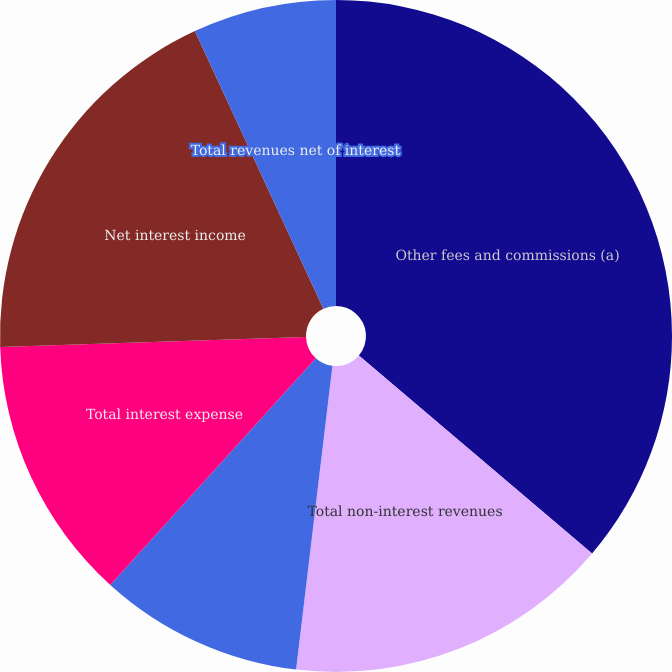<chart> <loc_0><loc_0><loc_500><loc_500><pie_chart><fcel>Other fees and commissions (a)<fcel>Total non-interest revenues<fcel>Total interest income<fcel>Total interest expense<fcel>Net interest income<fcel>Total revenues net of interest<nl><fcel>36.21%<fcel>15.69%<fcel>9.83%<fcel>12.76%<fcel>18.62%<fcel>6.9%<nl></chart> 